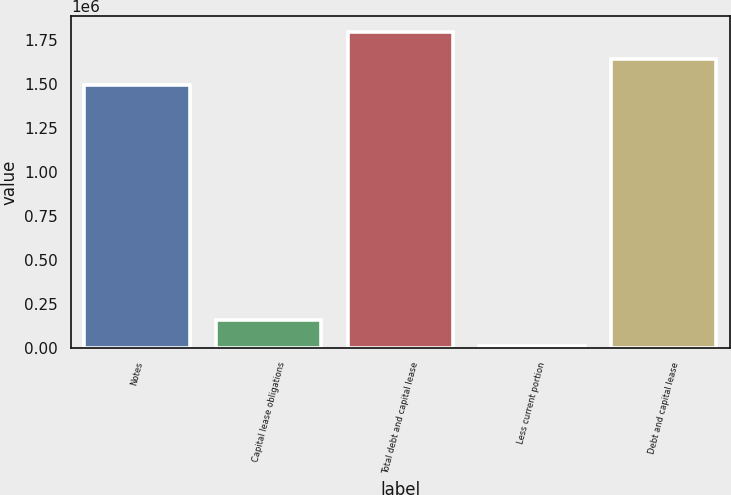Convert chart. <chart><loc_0><loc_0><loc_500><loc_500><bar_chart><fcel>Notes<fcel>Capital lease obligations<fcel>Total debt and capital lease<fcel>Less current portion<fcel>Debt and capital lease<nl><fcel>1.49463e+06<fcel>159722<fcel>1.79565e+06<fcel>9212<fcel>1.64514e+06<nl></chart> 